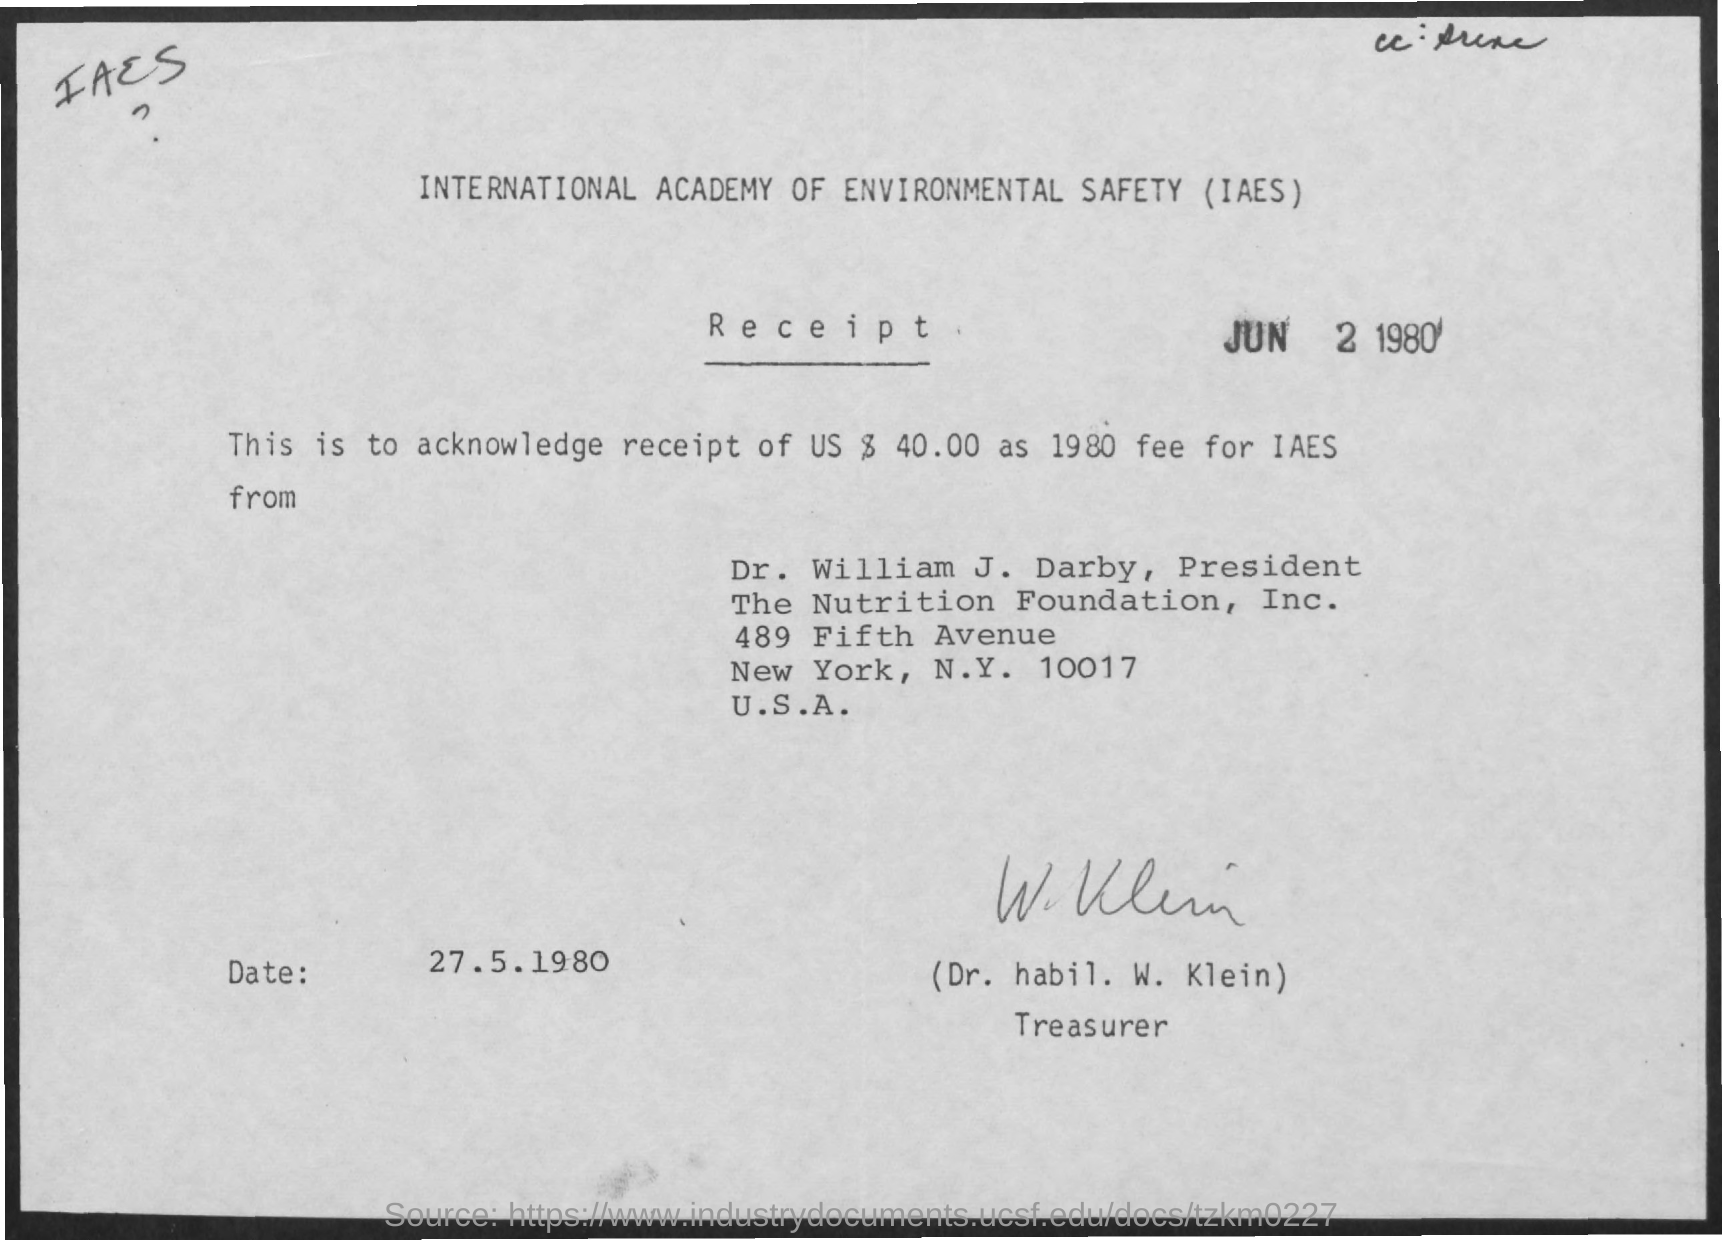Who is the treasurer mentioned in the document ?
Offer a terse response. Dr. habil. w. klein. Who is the president of the nutrition foundation ?
Make the answer very short. Dr. william j. darby. 